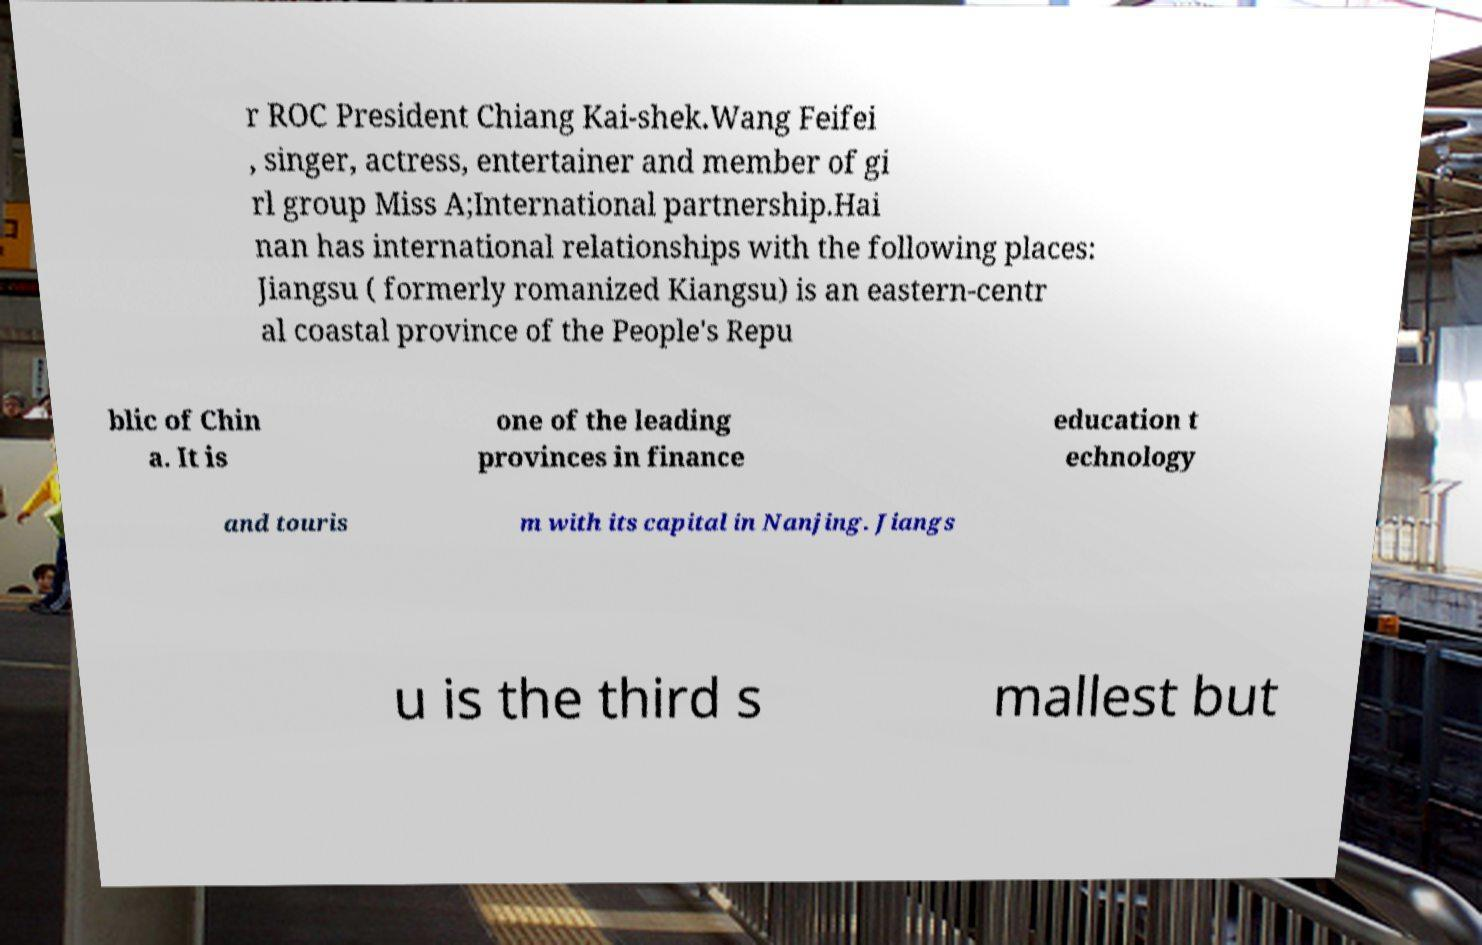I need the written content from this picture converted into text. Can you do that? r ROC President Chiang Kai-shek.Wang Feifei , singer, actress, entertainer and member of gi rl group Miss A;International partnership.Hai nan has international relationships with the following places: Jiangsu ( formerly romanized Kiangsu) is an eastern-centr al coastal province of the People's Repu blic of Chin a. It is one of the leading provinces in finance education t echnology and touris m with its capital in Nanjing. Jiangs u is the third s mallest but 